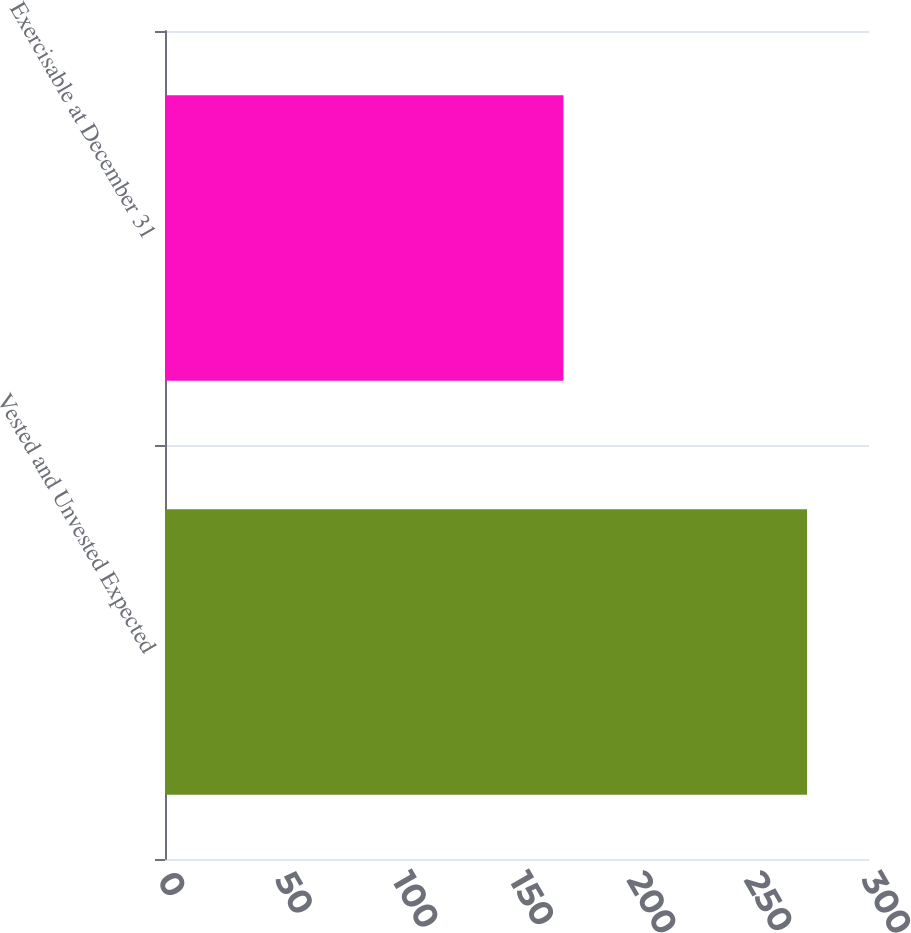Convert chart. <chart><loc_0><loc_0><loc_500><loc_500><bar_chart><fcel>Vested and Unvested Expected<fcel>Exercisable at December 31<nl><fcel>273.6<fcel>169.8<nl></chart> 